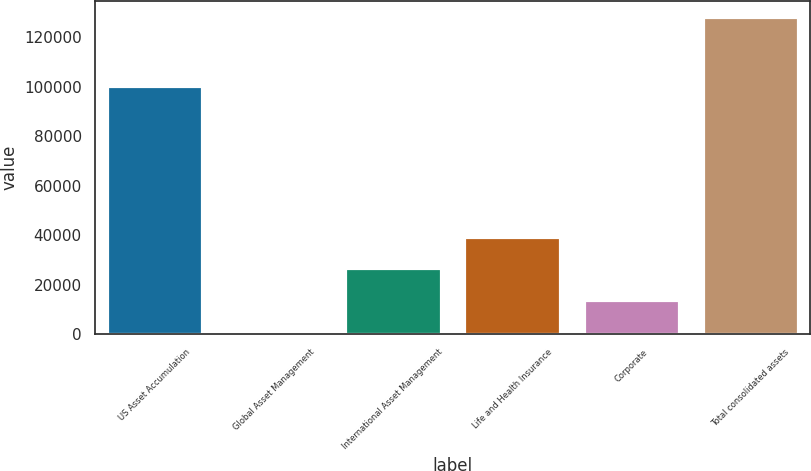Convert chart to OTSL. <chart><loc_0><loc_0><loc_500><loc_500><bar_chart><fcel>US Asset Accumulation<fcel>Global Asset Management<fcel>International Asset Management<fcel>Life and Health Insurance<fcel>Corporate<fcel>Total consolidated assets<nl><fcel>100469<fcel>1320.6<fcel>26693<fcel>39379.1<fcel>14006.8<fcel>128182<nl></chart> 